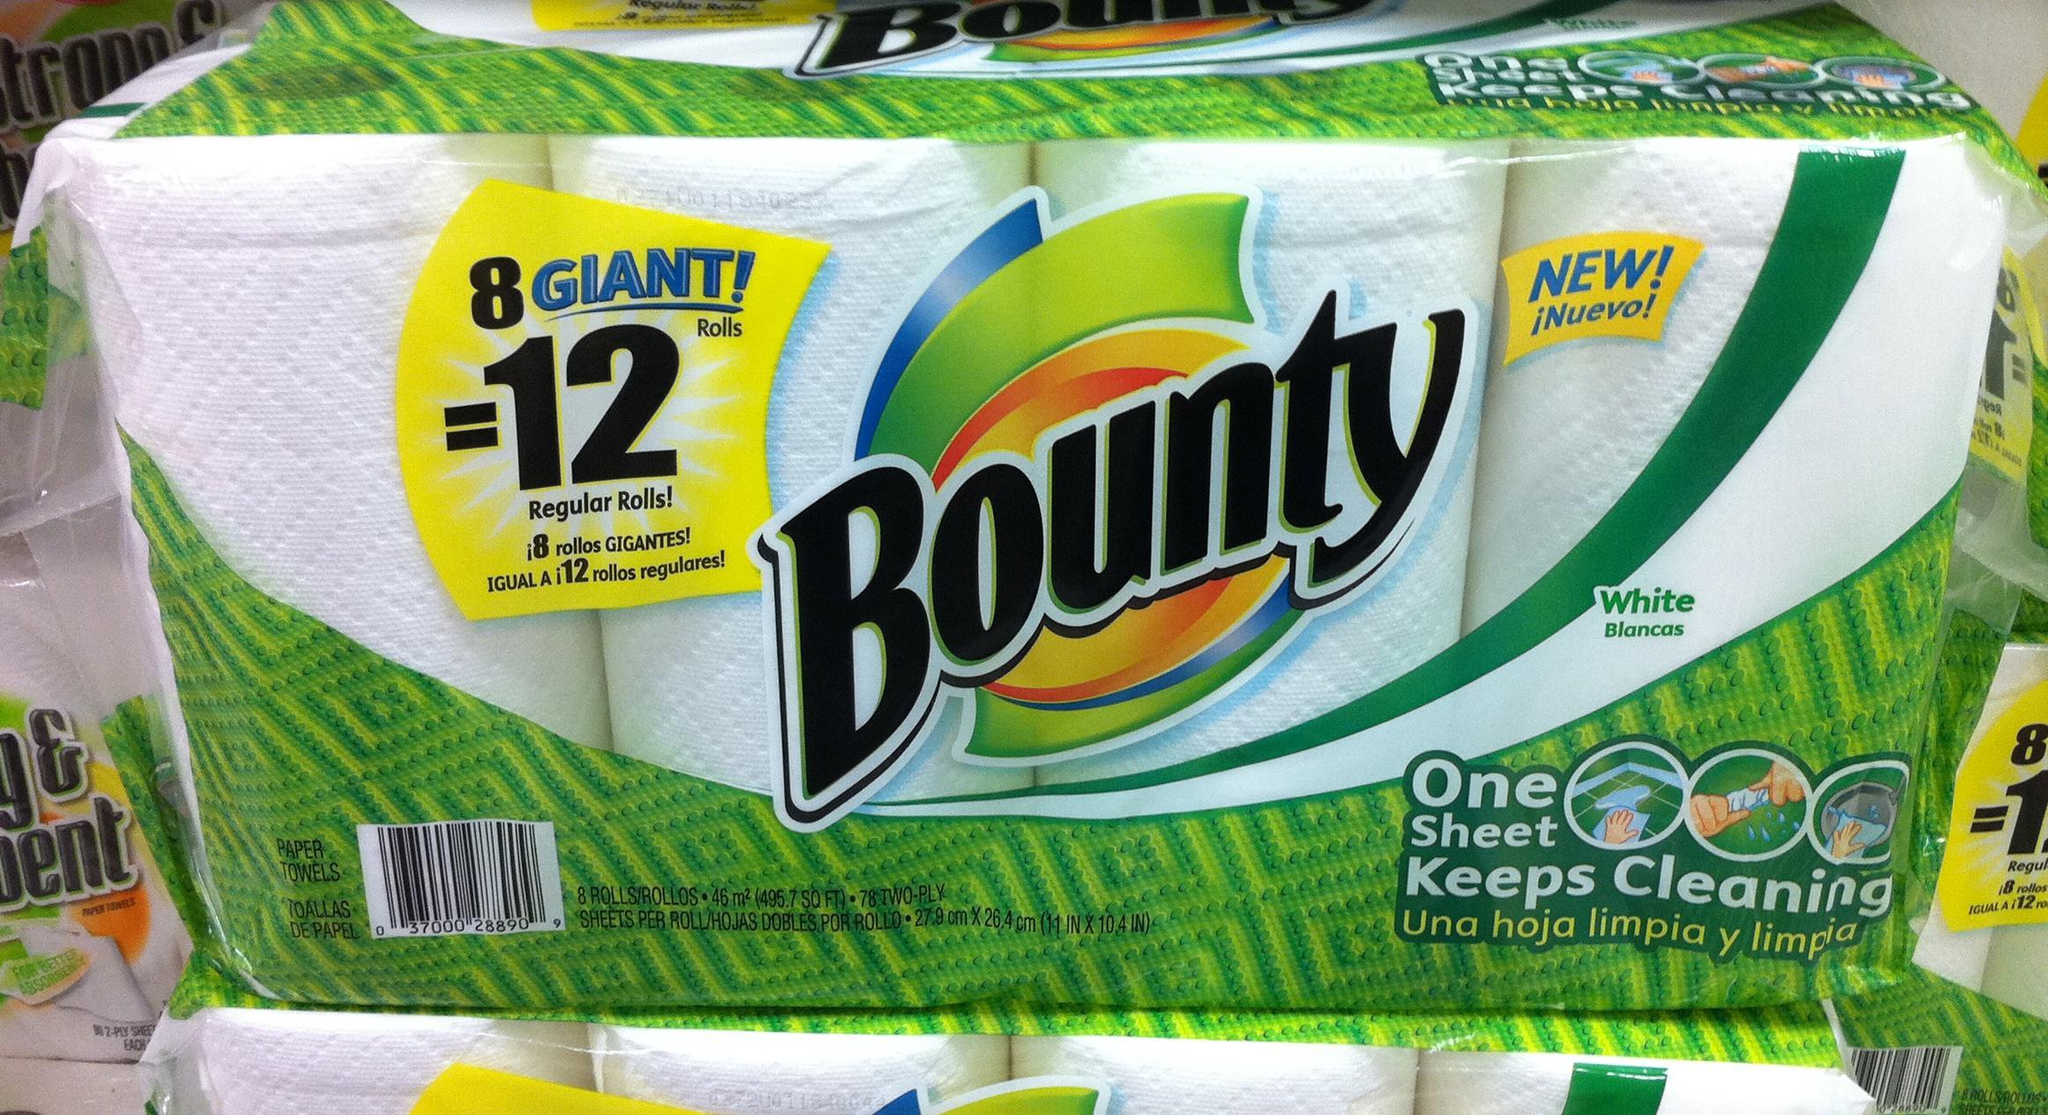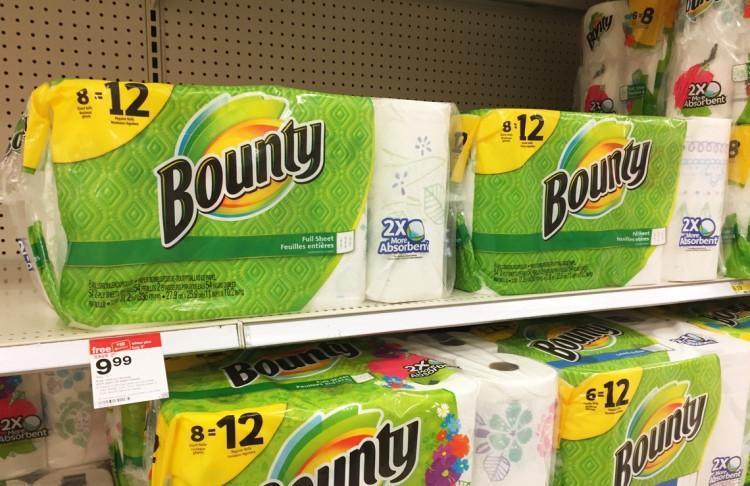The first image is the image on the left, the second image is the image on the right. Given the left and right images, does the statement "Right image shows a pack of paper towels on a store shelf with pegboard and a price sign visible." hold true? Answer yes or no. Yes. The first image is the image on the left, the second image is the image on the right. Assess this claim about the two images: "In one of the images there is a single rectangular multi-pack of paper towels.". Correct or not? Answer yes or no. No. 